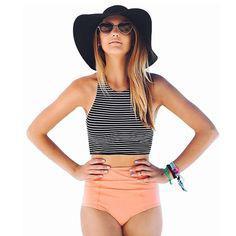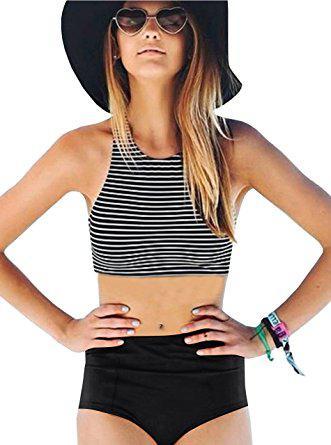The first image is the image on the left, the second image is the image on the right. Examine the images to the left and right. Is the description "At least one of the images shows a very low-rise bikini bottom that hits well below the belly button." accurate? Answer yes or no. No. 